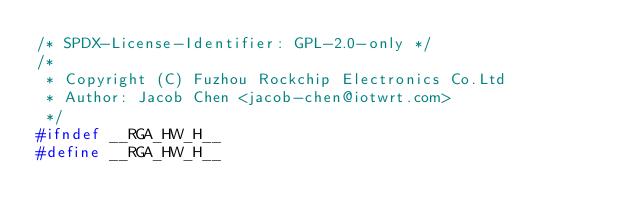Convert code to text. <code><loc_0><loc_0><loc_500><loc_500><_C_>/* SPDX-License-Identifier: GPL-2.0-only */
/*
 * Copyright (C) Fuzhou Rockchip Electronics Co.Ltd
 * Author: Jacob Chen <jacob-chen@iotwrt.com>
 */
#ifndef __RGA_HW_H__
#define __RGA_HW_H__
</code> 